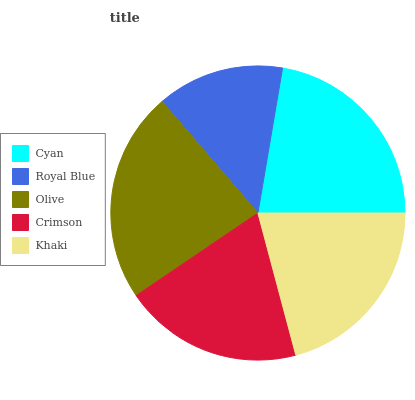Is Royal Blue the minimum?
Answer yes or no. Yes. Is Olive the maximum?
Answer yes or no. Yes. Is Olive the minimum?
Answer yes or no. No. Is Royal Blue the maximum?
Answer yes or no. No. Is Olive greater than Royal Blue?
Answer yes or no. Yes. Is Royal Blue less than Olive?
Answer yes or no. Yes. Is Royal Blue greater than Olive?
Answer yes or no. No. Is Olive less than Royal Blue?
Answer yes or no. No. Is Khaki the high median?
Answer yes or no. Yes. Is Khaki the low median?
Answer yes or no. Yes. Is Olive the high median?
Answer yes or no. No. Is Cyan the low median?
Answer yes or no. No. 